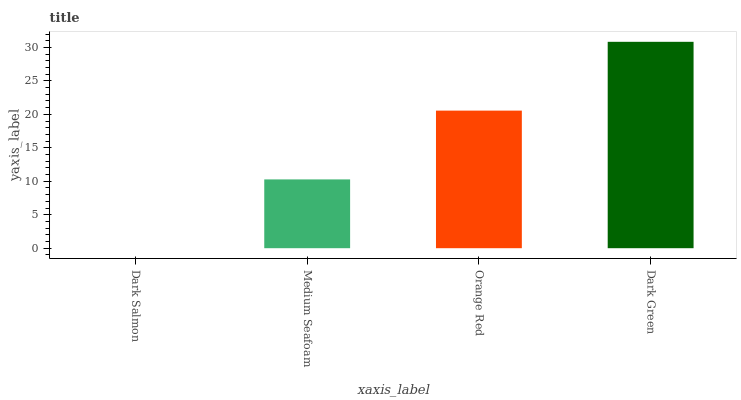Is Dark Salmon the minimum?
Answer yes or no. Yes. Is Dark Green the maximum?
Answer yes or no. Yes. Is Medium Seafoam the minimum?
Answer yes or no. No. Is Medium Seafoam the maximum?
Answer yes or no. No. Is Medium Seafoam greater than Dark Salmon?
Answer yes or no. Yes. Is Dark Salmon less than Medium Seafoam?
Answer yes or no. Yes. Is Dark Salmon greater than Medium Seafoam?
Answer yes or no. No. Is Medium Seafoam less than Dark Salmon?
Answer yes or no. No. Is Orange Red the high median?
Answer yes or no. Yes. Is Medium Seafoam the low median?
Answer yes or no. Yes. Is Medium Seafoam the high median?
Answer yes or no. No. Is Dark Green the low median?
Answer yes or no. No. 